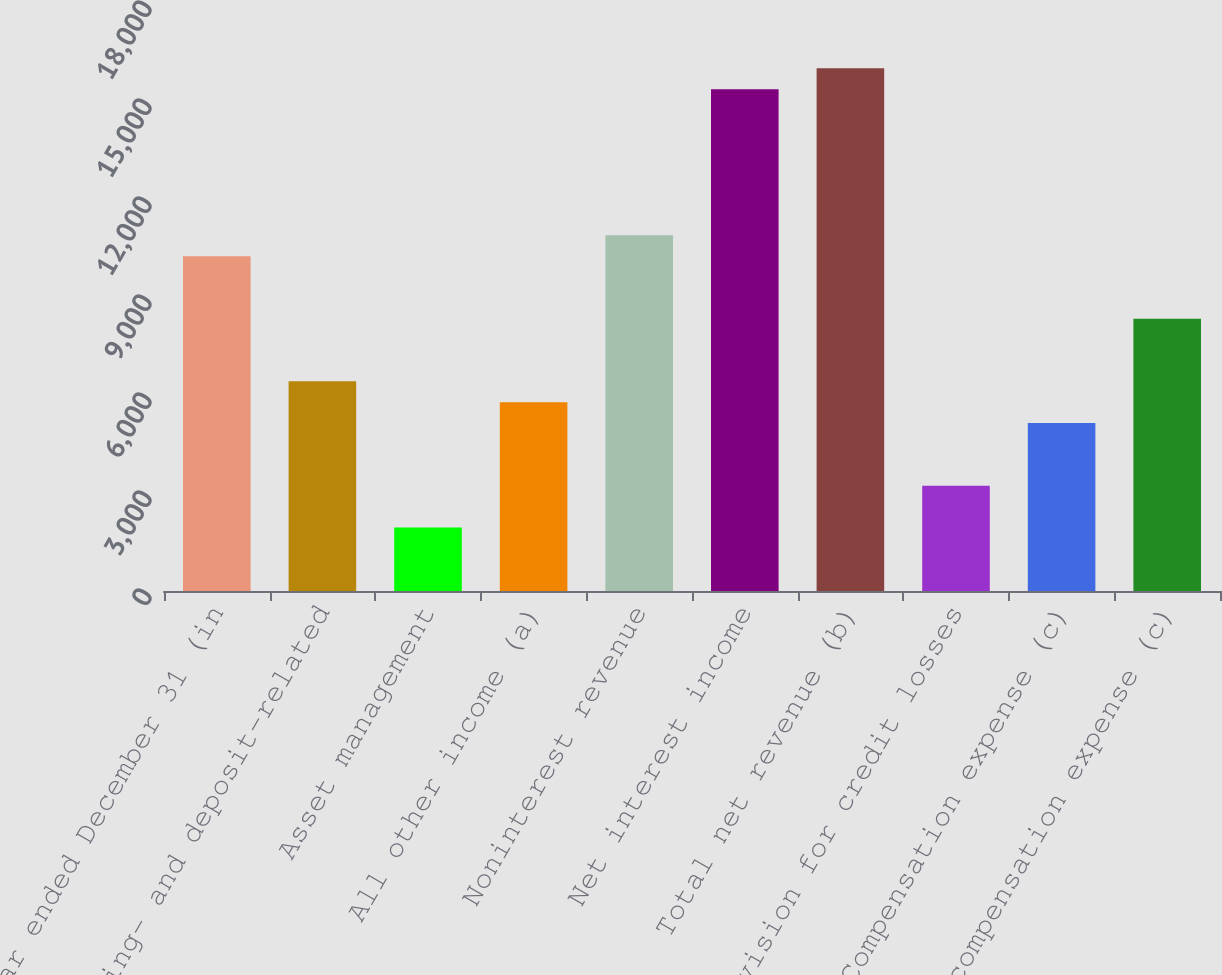Convert chart. <chart><loc_0><loc_0><loc_500><loc_500><bar_chart><fcel>Year ended December 31 (in<fcel>Lending- and deposit-related<fcel>Asset management<fcel>All other income (a)<fcel>Noninterest revenue<fcel>Net interest income<fcel>Total net revenue (b)<fcel>Provision for credit losses<fcel>Compensation expense (c)<fcel>Noncompensation expense (c)<nl><fcel>10250.8<fcel>6418<fcel>1946.4<fcel>5779.2<fcel>10889.6<fcel>15361.2<fcel>16000<fcel>3224<fcel>5140.4<fcel>8334.4<nl></chart> 